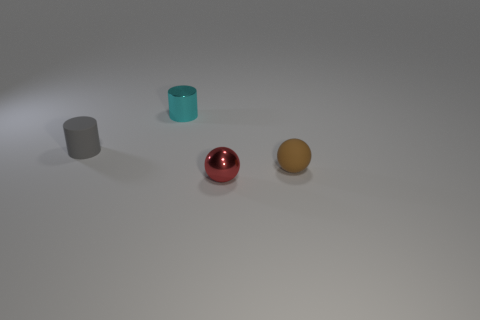There is a cyan metal thing; how many matte objects are on the left side of it?
Offer a terse response. 1. Is the number of small shiny cylinders greater than the number of small brown shiny balls?
Keep it short and to the point. Yes. There is a metal thing that is in front of the small cylinder on the right side of the matte cylinder; what shape is it?
Your response must be concise. Sphere. Is the number of tiny things that are behind the matte sphere greater than the number of tiny cyan cylinders?
Your response must be concise. Yes. There is a rubber thing that is on the left side of the red ball; how many cyan things are in front of it?
Your response must be concise. 0. Do the small sphere that is behind the tiny red ball and the sphere that is left of the matte ball have the same material?
Your answer should be compact. No. How many small red objects have the same shape as the gray object?
Make the answer very short. 0. Are the small gray object and the tiny thing that is to the right of the metal ball made of the same material?
Offer a very short reply. Yes. There is a gray cylinder that is the same size as the brown ball; what is it made of?
Your response must be concise. Rubber. Are there any other rubber objects of the same size as the brown rubber object?
Your answer should be compact. Yes. 